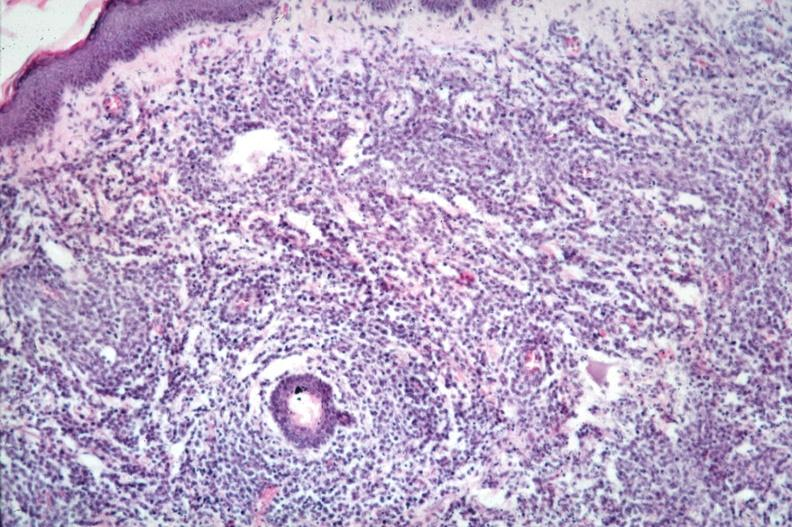s lymphoblastic lymphoma present?
Answer the question using a single word or phrase. Yes 